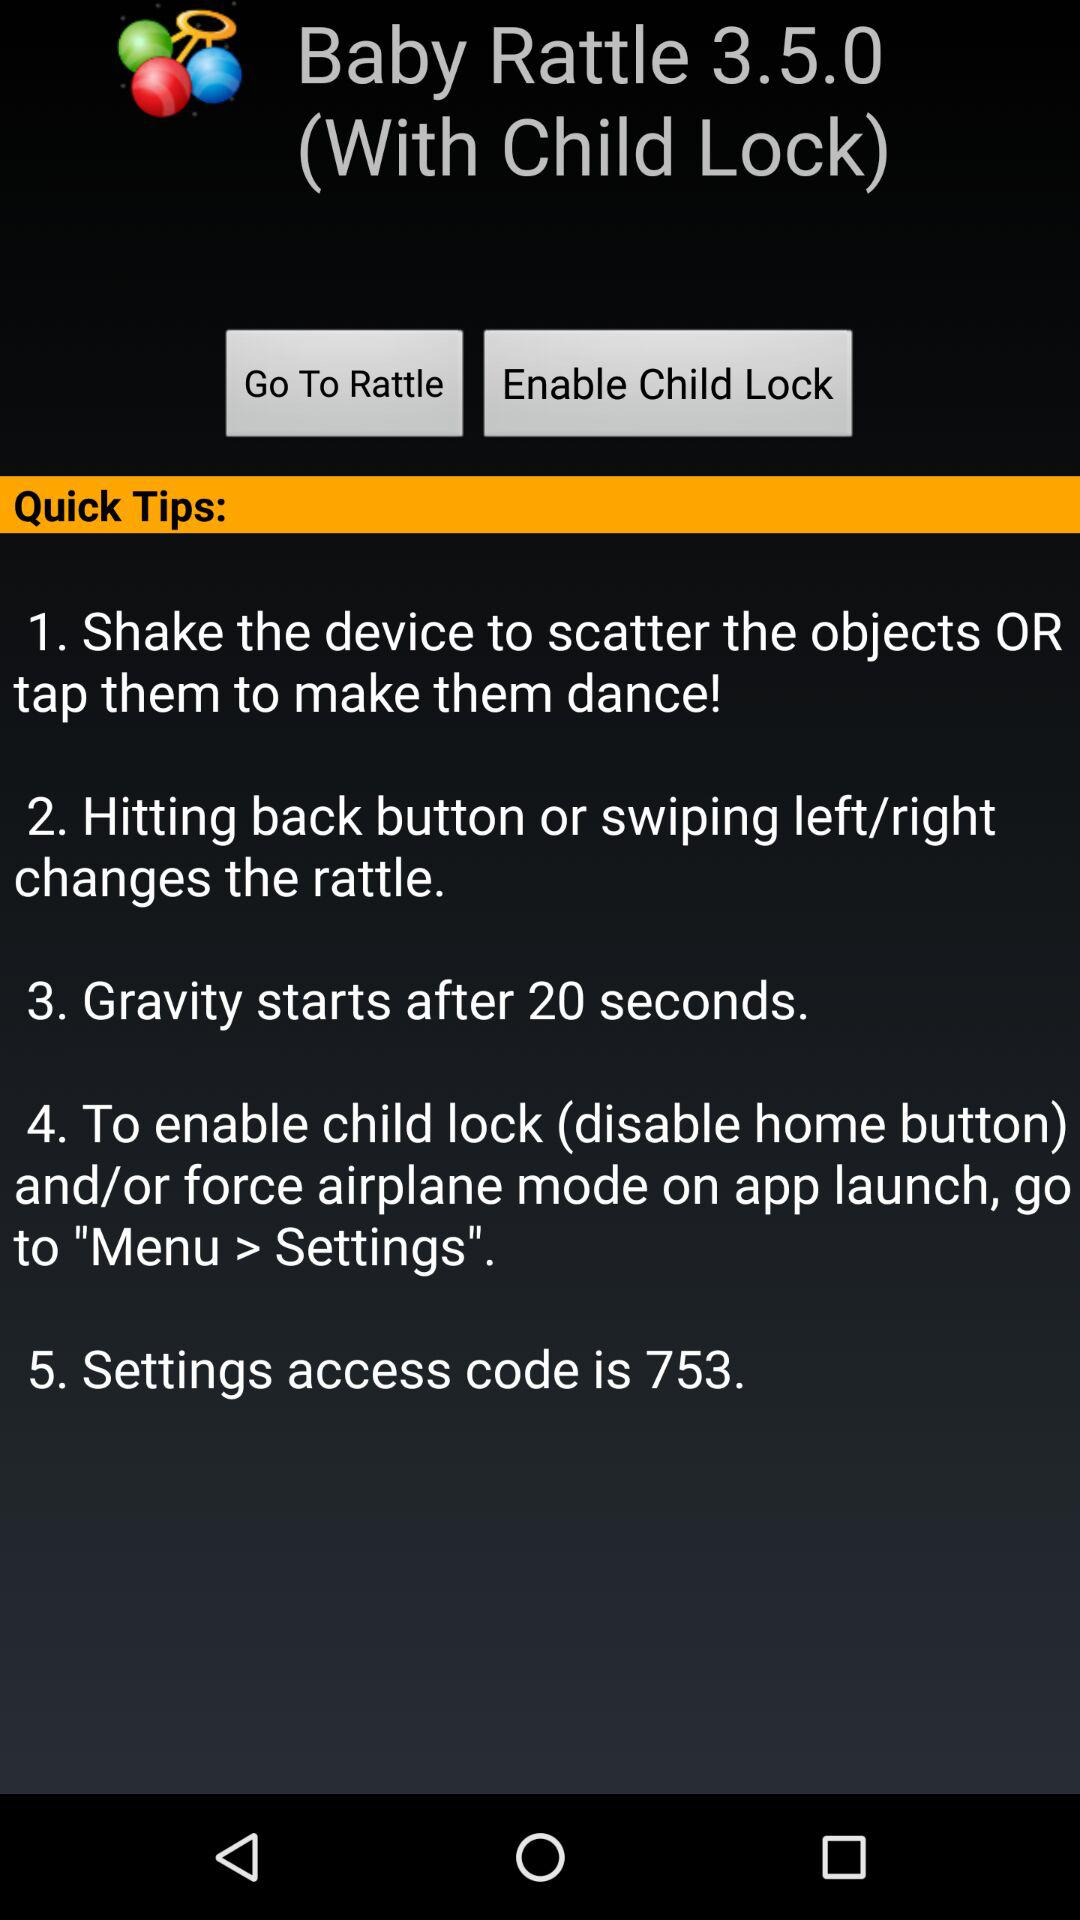What is the application name? The application name is "Baby Rattle". 